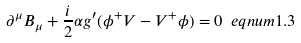<formula> <loc_0><loc_0><loc_500><loc_500>\partial ^ { \mu } B _ { \mu } + \frac { i } { 2 } \alpha g ^ { \prime } ( \phi ^ { + } V - V ^ { + } \phi ) = 0 \ e q n u m { 1 . 3 }</formula> 